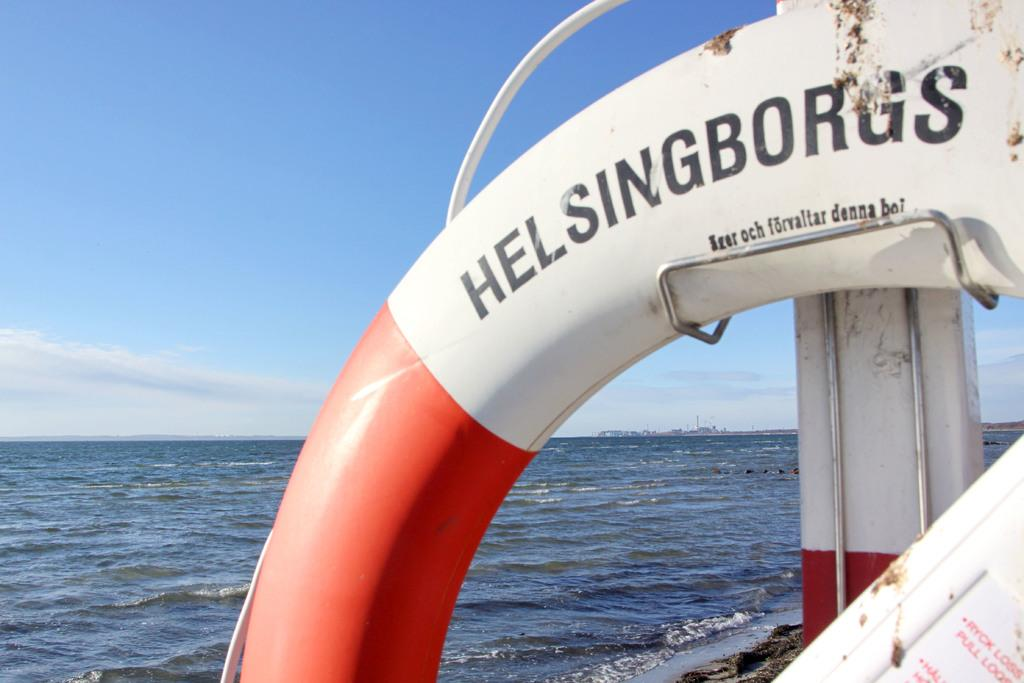<image>
Relay a brief, clear account of the picture shown. the life saver for this boat says Helsingborgs 